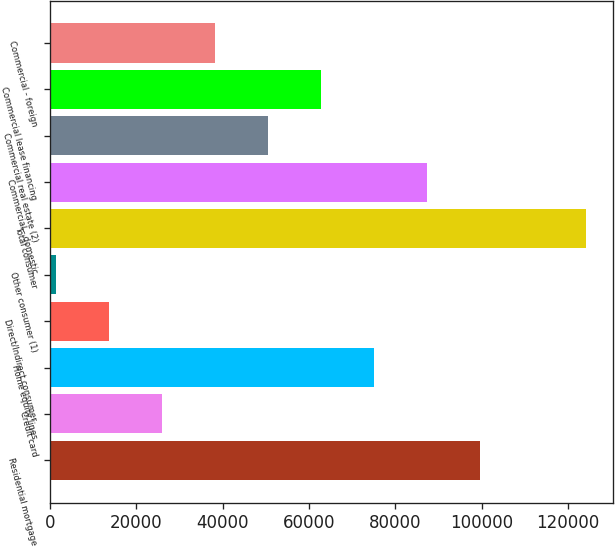<chart> <loc_0><loc_0><loc_500><loc_500><bar_chart><fcel>Residential mortgage<fcel>Credit card<fcel>Home equity lines<fcel>Direct/Indirect consumer<fcel>Other consumer (1)<fcel>Total consumer<fcel>Commercial - domestic<fcel>Commercial real estate (2)<fcel>Commercial lease financing<fcel>Commercial - foreign<nl><fcel>99663.2<fcel>25869.8<fcel>75065.4<fcel>13570.9<fcel>1272<fcel>124261<fcel>87364.3<fcel>50467.6<fcel>62766.5<fcel>38168.7<nl></chart> 